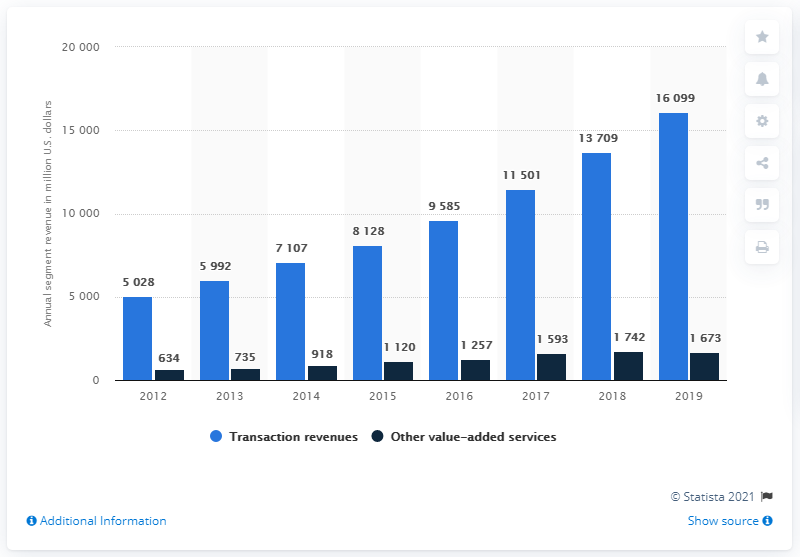What can be inferred about the relationship between transaction revenues and other value-added services from this chart? This chart illustrates that, generally, transaction revenues significantly outpace those of other value-added services. While both categories show growth over time, transaction revenues have a much steeper increase, reflecting a larger scale of business or a more profitable pricing model. This difference highlights the predominant financial contribution of transactions compared to other services in this context. 